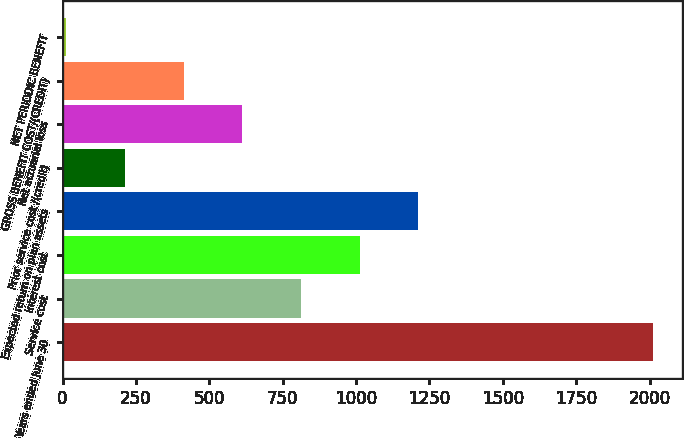Convert chart to OTSL. <chart><loc_0><loc_0><loc_500><loc_500><bar_chart><fcel>Years ended June 30<fcel>Service cost<fcel>Interest cost<fcel>Expected return on plan assets<fcel>Prior service cost /(credit)<fcel>Net actuarial loss<fcel>GROSS BENEFIT COST/(CREDIT)<fcel>NET PERIODIC BENEFIT<nl><fcel>2011<fcel>812.2<fcel>1012<fcel>1211.8<fcel>212.8<fcel>612.4<fcel>412.6<fcel>13<nl></chart> 